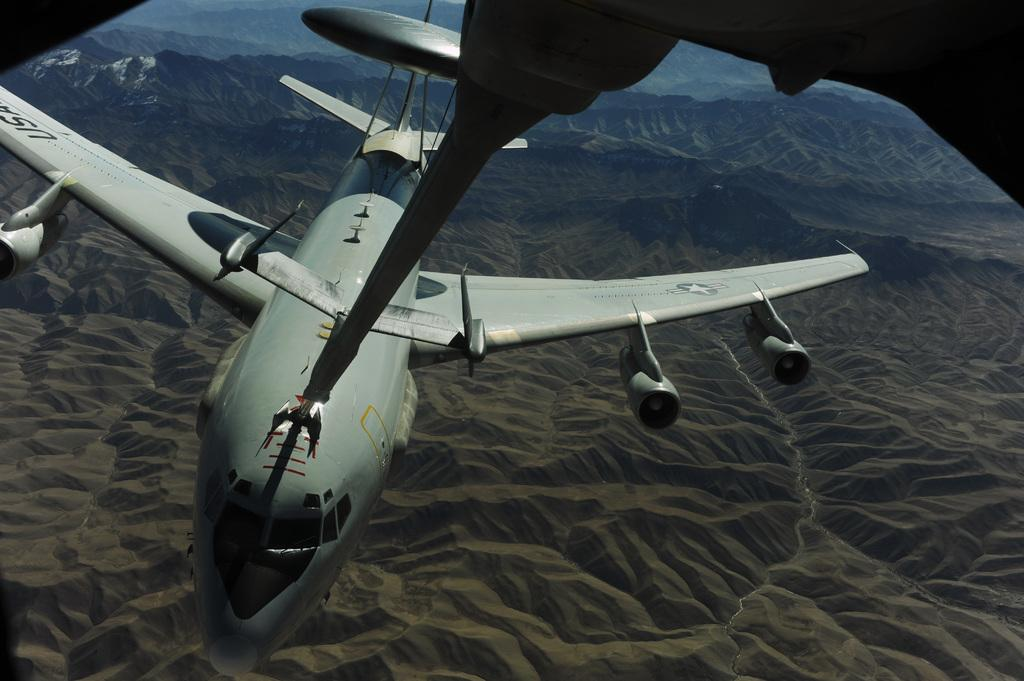What is the main subject of the image? The main subject of the image is an airplane. Can you describe any specific features of the airplane? Yes, the airplane appears to have an attachment on its top. What can be seen in the background of the image? In the background of the image, there are mountains and a river visible. Can you tell me how many balloons are tied to the airplane in the image? There are no balloons present in the image; it features an airplane with an attachment on its top. What type of kitty can be seen flying alongside the airplane in the image? There is no kitty present in the image; it only features an airplane with an attachment on its top and a background with mountains and a river. 